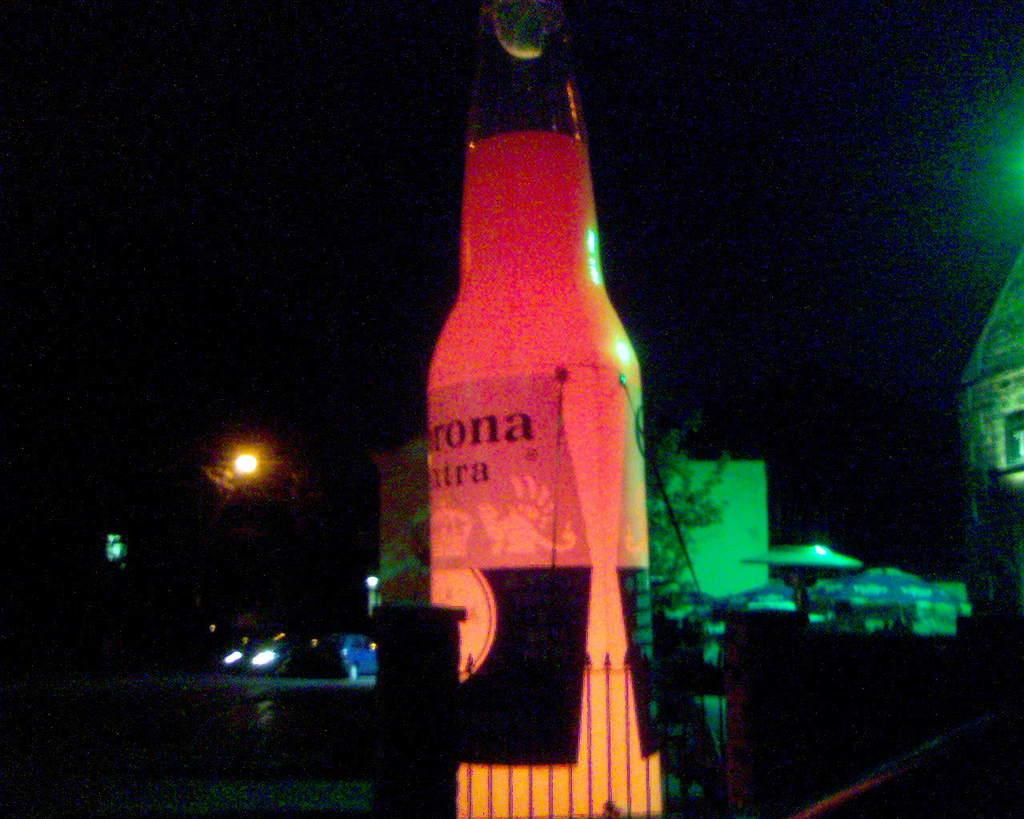What is the main object in the image? There is a big bottle in the image. What can be found on the bottle? The bottle has a label on it. What type of structure can be seen in the image? There is a street light in the image. What else is present in the image besides the bottle? Vehicles, a building, and plants are visible in the image. How would you describe the lighting in the image? The background of the image is dark. What type of orange is being taught how to use a rifle in the image? There is no orange or rifle present in the image. What subject is the teacher instructing in the image? There is no teaching or teacher present in the image. 